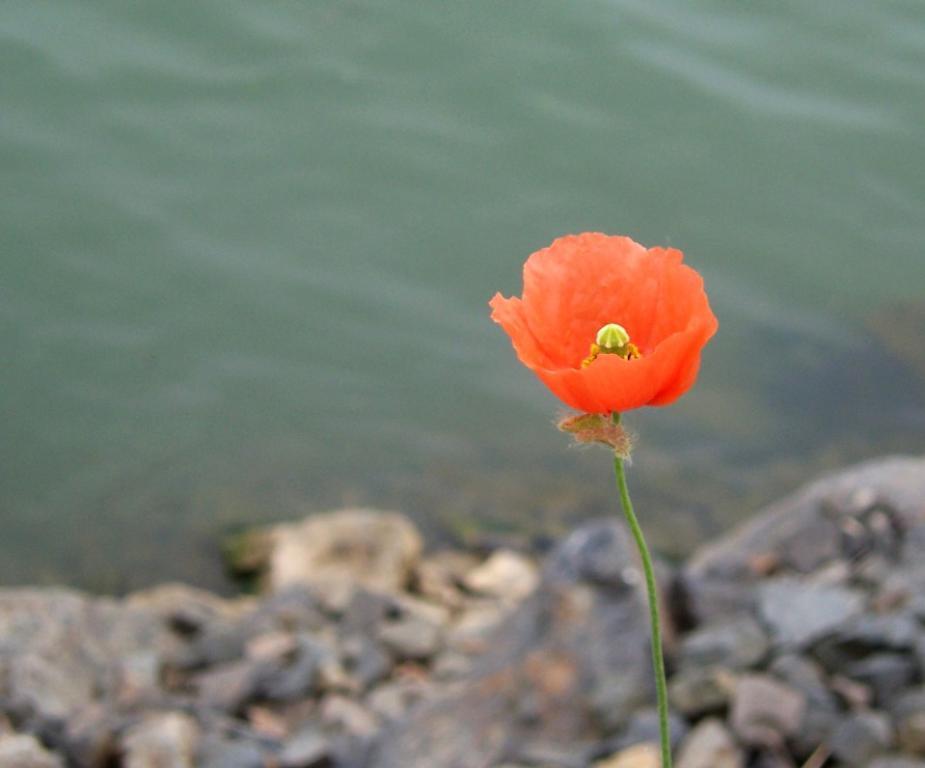Could you give a brief overview of what you see in this image? This image is taken outdoors. At the bottom of the image there are a few stones on the ground. At the top of the image there is a pond. On the right side of the image there is a flower which is red in color. 